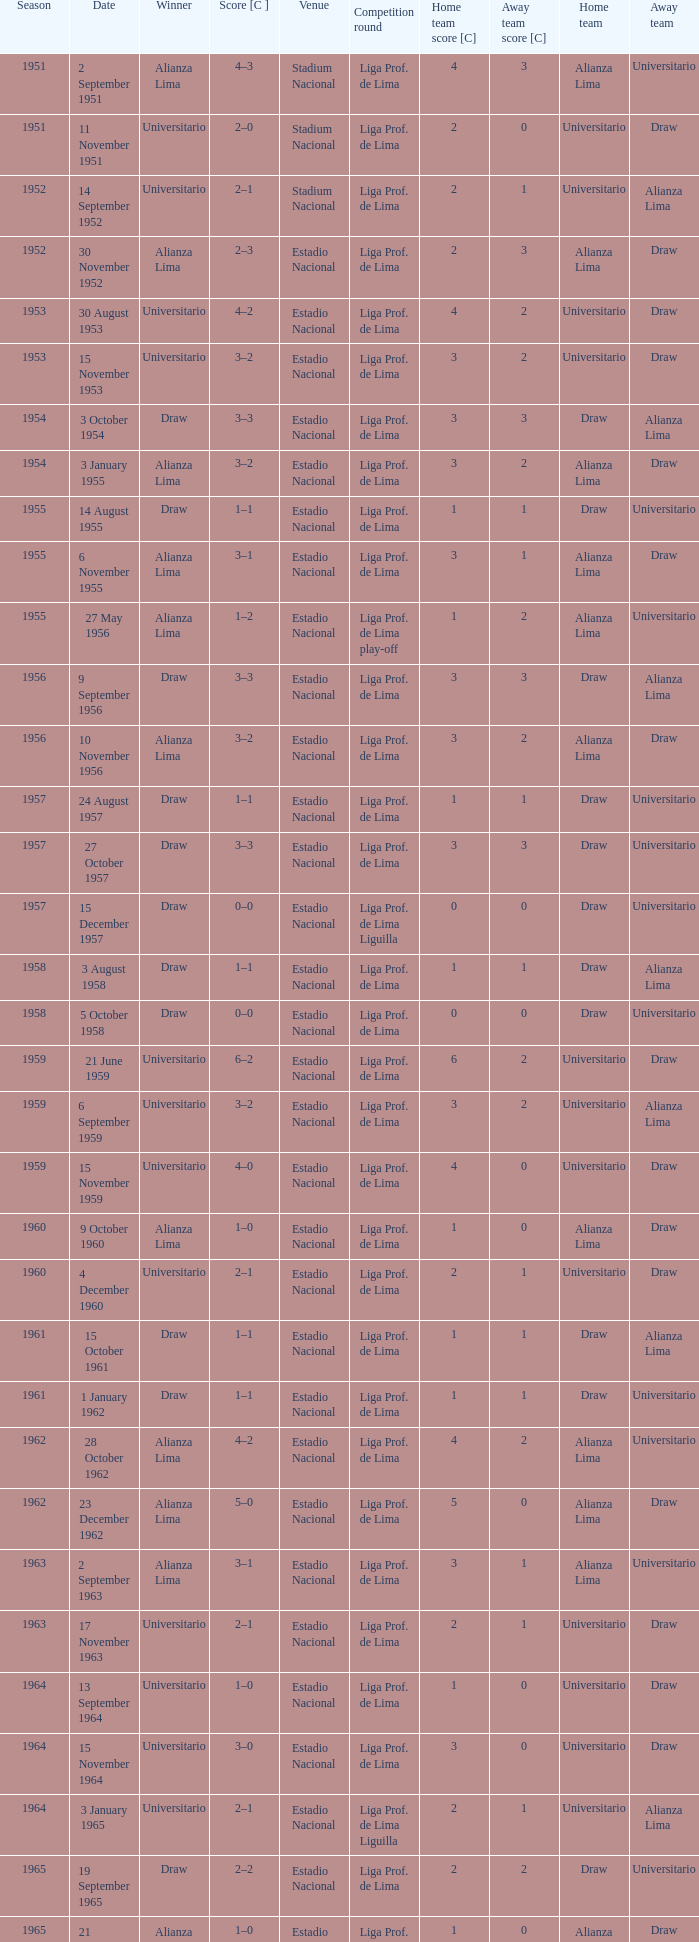What was the outcome in terms of points for the 1965 event won by alianza lima? 1–0. Can you give me this table as a dict? {'header': ['Season', 'Date', 'Winner', 'Score [C ]', 'Venue', 'Competition round', 'Home team score [C]', 'Away team score [C]', 'Home team', 'Away team'], 'rows': [['1951', '2 September 1951', 'Alianza Lima', '4–3', 'Stadium Nacional', 'Liga Prof. de Lima', '4', '3', 'Alianza Lima', 'Universitario'], ['1951', '11 November 1951', 'Universitario', '2–0', 'Stadium Nacional', 'Liga Prof. de Lima', '2', '0', 'Universitario', 'Draw'], ['1952', '14 September 1952', 'Universitario', '2–1', 'Stadium Nacional', 'Liga Prof. de Lima', '2', '1', 'Universitario', 'Alianza Lima'], ['1952', '30 November 1952', 'Alianza Lima', '2–3', 'Estadio Nacional', 'Liga Prof. de Lima', '2', '3', 'Alianza Lima', 'Draw'], ['1953', '30 August 1953', 'Universitario', '4–2', 'Estadio Nacional', 'Liga Prof. de Lima', '4', '2', 'Universitario', 'Draw'], ['1953', '15 November 1953', 'Universitario', '3–2', 'Estadio Nacional', 'Liga Prof. de Lima', '3', '2', 'Universitario', 'Draw'], ['1954', '3 October 1954', 'Draw', '3–3', 'Estadio Nacional', 'Liga Prof. de Lima', '3', '3', 'Draw', 'Alianza Lima'], ['1954', '3 January 1955', 'Alianza Lima', '3–2', 'Estadio Nacional', 'Liga Prof. de Lima', '3', '2', 'Alianza Lima', 'Draw'], ['1955', '14 August 1955', 'Draw', '1–1', 'Estadio Nacional', 'Liga Prof. de Lima', '1', '1', 'Draw', 'Universitario'], ['1955', '6 November 1955', 'Alianza Lima', '3–1', 'Estadio Nacional', 'Liga Prof. de Lima', '3', '1', 'Alianza Lima', 'Draw'], ['1955', '27 May 1956', 'Alianza Lima', '1–2', 'Estadio Nacional', 'Liga Prof. de Lima play-off', '1', '2', 'Alianza Lima', 'Universitario'], ['1956', '9 September 1956', 'Draw', '3–3', 'Estadio Nacional', 'Liga Prof. de Lima', '3', '3', 'Draw', 'Alianza Lima'], ['1956', '10 November 1956', 'Alianza Lima', '3–2', 'Estadio Nacional', 'Liga Prof. de Lima', '3', '2', 'Alianza Lima', 'Draw'], ['1957', '24 August 1957', 'Draw', '1–1', 'Estadio Nacional', 'Liga Prof. de Lima', '1', '1', 'Draw', 'Universitario'], ['1957', '27 October 1957', 'Draw', '3–3', 'Estadio Nacional', 'Liga Prof. de Lima', '3', '3', 'Draw', 'Universitario'], ['1957', '15 December 1957', 'Draw', '0–0', 'Estadio Nacional', 'Liga Prof. de Lima Liguilla', '0', '0', 'Draw', 'Universitario'], ['1958', '3 August 1958', 'Draw', '1–1', 'Estadio Nacional', 'Liga Prof. de Lima', '1', '1', 'Draw', 'Alianza Lima'], ['1958', '5 October 1958', 'Draw', '0–0', 'Estadio Nacional', 'Liga Prof. de Lima', '0', '0', 'Draw', 'Universitario'], ['1959', '21 June 1959', 'Universitario', '6–2', 'Estadio Nacional', 'Liga Prof. de Lima', '6', '2', 'Universitario', 'Draw'], ['1959', '6 September 1959', 'Universitario', '3–2', 'Estadio Nacional', 'Liga Prof. de Lima', '3', '2', 'Universitario', 'Alianza Lima'], ['1959', '15 November 1959', 'Universitario', '4–0', 'Estadio Nacional', 'Liga Prof. de Lima', '4', '0', 'Universitario', 'Draw'], ['1960', '9 October 1960', 'Alianza Lima', '1–0', 'Estadio Nacional', 'Liga Prof. de Lima', '1', '0', 'Alianza Lima', 'Draw'], ['1960', '4 December 1960', 'Universitario', '2–1', 'Estadio Nacional', 'Liga Prof. de Lima', '2', '1', 'Universitario', 'Draw'], ['1961', '15 October 1961', 'Draw', '1–1', 'Estadio Nacional', 'Liga Prof. de Lima', '1', '1', 'Draw', 'Alianza Lima'], ['1961', '1 January 1962', 'Draw', '1–1', 'Estadio Nacional', 'Liga Prof. de Lima', '1', '1', 'Draw', 'Universitario'], ['1962', '28 October 1962', 'Alianza Lima', '4–2', 'Estadio Nacional', 'Liga Prof. de Lima', '4', '2', 'Alianza Lima', 'Universitario'], ['1962', '23 December 1962', 'Alianza Lima', '5–0', 'Estadio Nacional', 'Liga Prof. de Lima', '5', '0', 'Alianza Lima', 'Draw'], ['1963', '2 September 1963', 'Alianza Lima', '3–1', 'Estadio Nacional', 'Liga Prof. de Lima', '3', '1', 'Alianza Lima', 'Universitario'], ['1963', '17 November 1963', 'Universitario', '2–1', 'Estadio Nacional', 'Liga Prof. de Lima', '2', '1', 'Universitario', 'Draw'], ['1964', '13 September 1964', 'Universitario', '1–0', 'Estadio Nacional', 'Liga Prof. de Lima', '1', '0', 'Universitario', 'Draw'], ['1964', '15 November 1964', 'Universitario', '3–0', 'Estadio Nacional', 'Liga Prof. de Lima', '3', '0', 'Universitario', 'Draw'], ['1964', '3 January 1965', 'Universitario', '2–1', 'Estadio Nacional', 'Liga Prof. de Lima Liguilla', '2', '1', 'Universitario', 'Alianza Lima'], ['1965', '19 September 1965', 'Draw', '2–2', 'Estadio Nacional', 'Liga Prof. de Lima', '2', '2', 'Draw', 'Universitario'], ['1965', '21 November 1965', 'Alianza Lima', '1–0', 'Estadio Nacional', 'Liga Prof. de Lima', '1', '0', 'Alianza Lima', 'Draw'], ['1965', '19 December 1965', 'Universitario', '1–0', 'Estadio Nacional', 'Liga Prof. de Lima Liguilla', '1', '0', 'Universitario', 'Alianza Lima']]} 